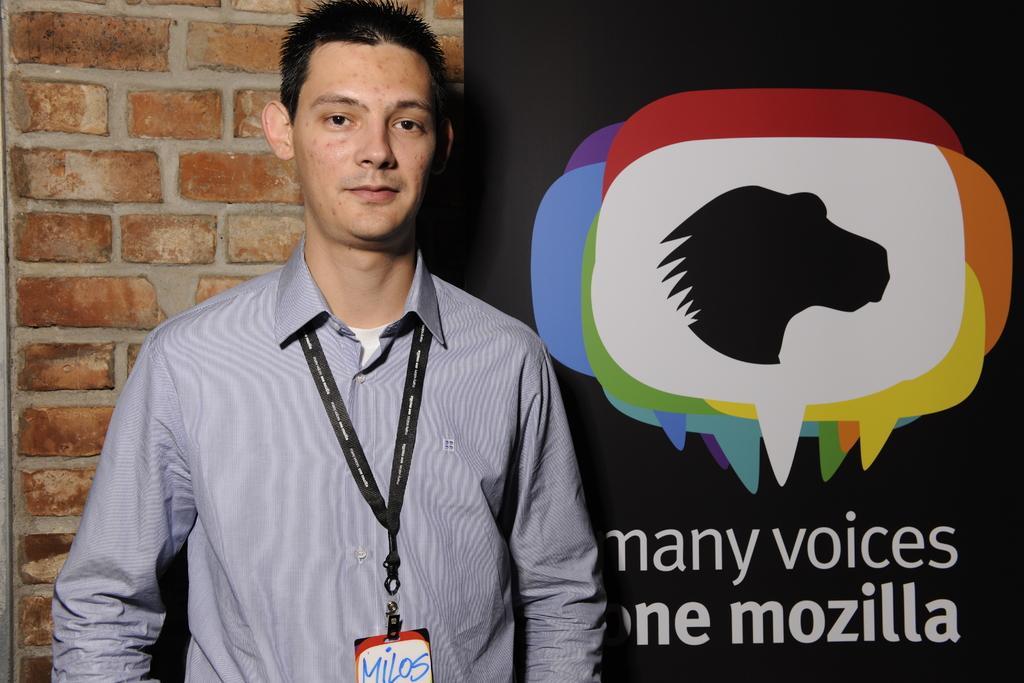Could you give a brief overview of what you see in this image? Here we can see a man standing and he wore a ID card on his neck. In the background there is a wall and hoarding. 